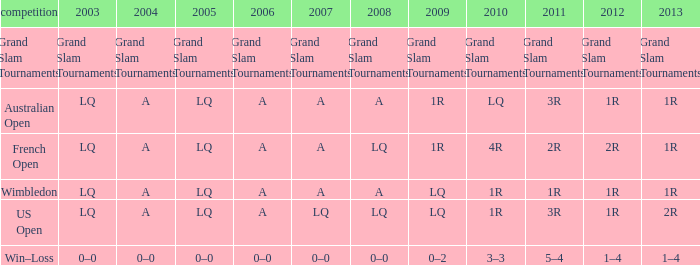Which year has a 2011 of 1r? A. 